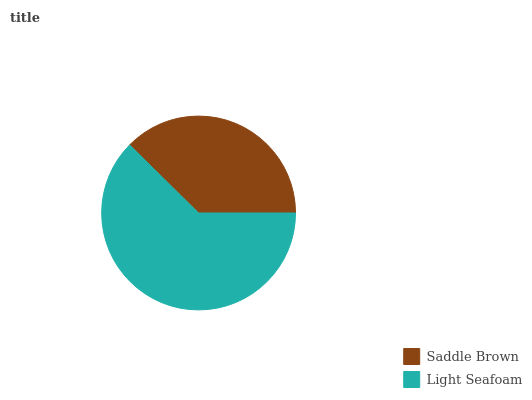Is Saddle Brown the minimum?
Answer yes or no. Yes. Is Light Seafoam the maximum?
Answer yes or no. Yes. Is Light Seafoam the minimum?
Answer yes or no. No. Is Light Seafoam greater than Saddle Brown?
Answer yes or no. Yes. Is Saddle Brown less than Light Seafoam?
Answer yes or no. Yes. Is Saddle Brown greater than Light Seafoam?
Answer yes or no. No. Is Light Seafoam less than Saddle Brown?
Answer yes or no. No. Is Light Seafoam the high median?
Answer yes or no. Yes. Is Saddle Brown the low median?
Answer yes or no. Yes. Is Saddle Brown the high median?
Answer yes or no. No. Is Light Seafoam the low median?
Answer yes or no. No. 